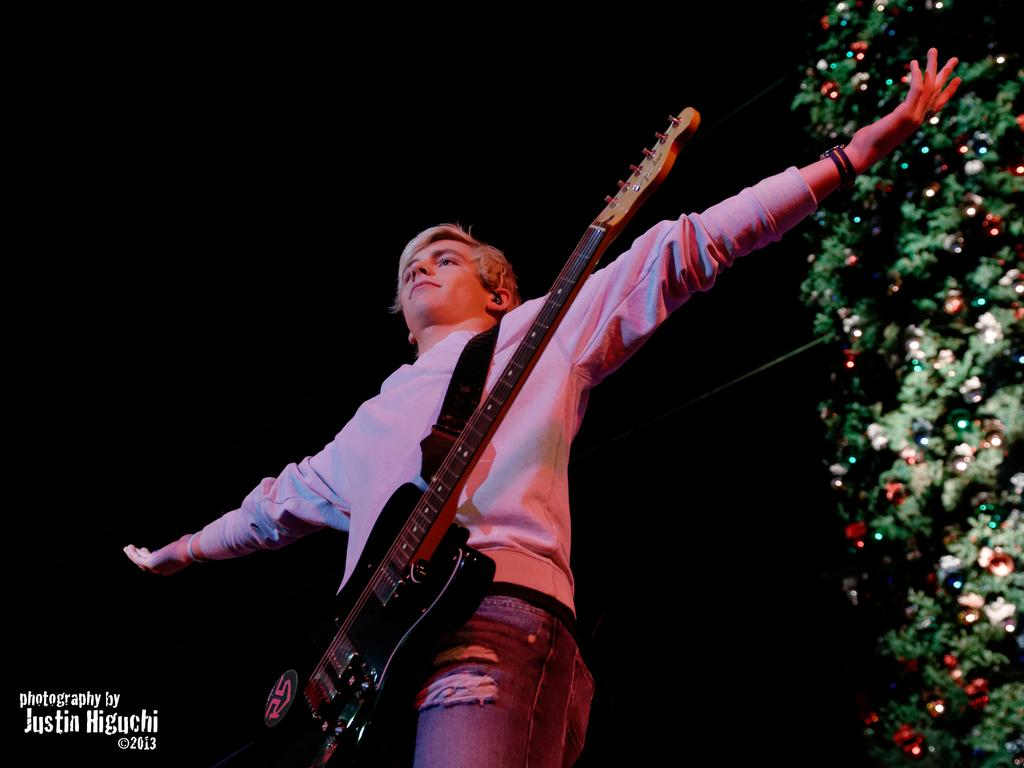Who is present in the image? There is a man in the image. What is the man doing in the image? The man is standing and stretching his hands. What object is the man holding in the image? The man is holding a guitar. What additional element can be seen in the image? There is a Christmas tree in the image. What type of flowers can be seen growing around the man in the image? There are no flowers present in the image. 